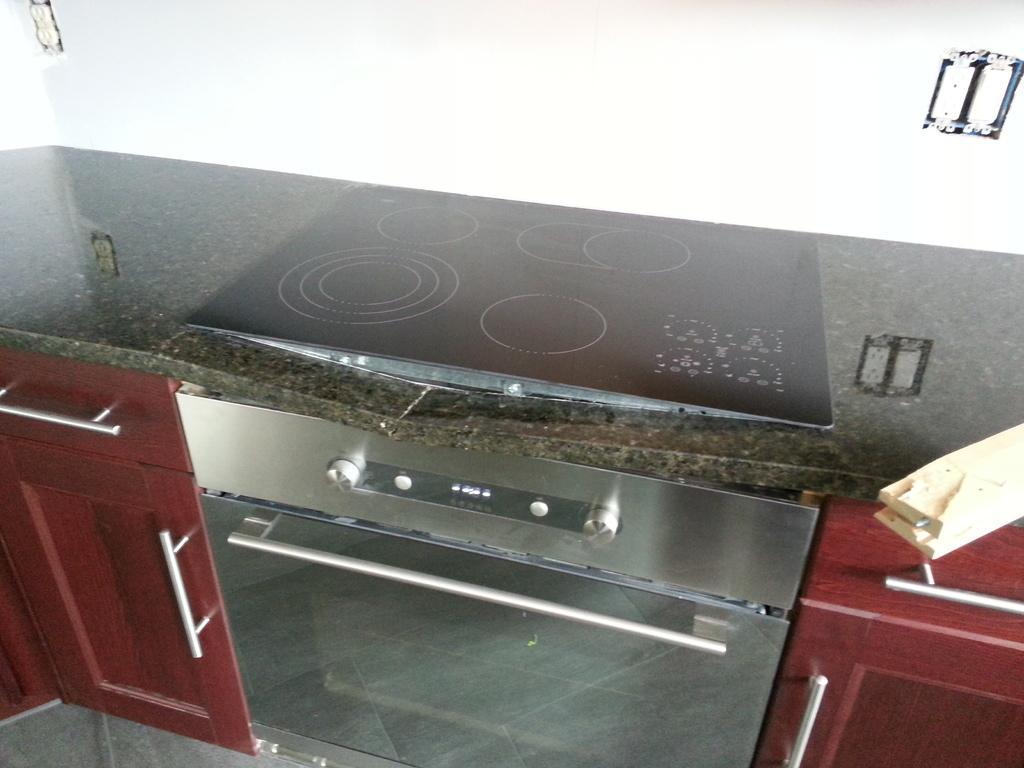In one or two sentences, can you explain what this image depicts? Here we can see cupboards and there is a stove on a platform. This is floor. In the background we can see wall. 